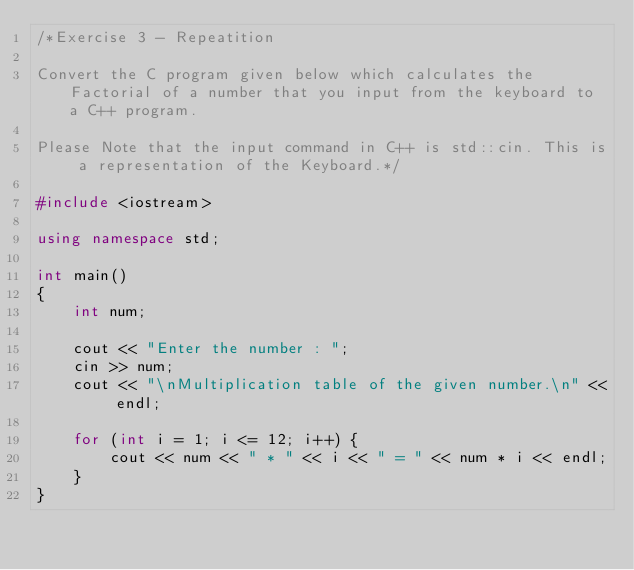Convert code to text. <code><loc_0><loc_0><loc_500><loc_500><_C++_>/*Exercise 3 - Repeatition

Convert the C program given below which calculates the Factorial of a number that you input from the keyboard to a C++ program.

Please Note that the input command in C++ is std::cin. This is a representation of the Keyboard.*/

#include <iostream>

using namespace std;

int main()
{
    int num;

    cout << "Enter the number : ";
    cin >> num;
    cout << "\nMultiplication table of the given number.\n" << endl;

    for (int i = 1; i <= 12; i++) {
        cout << num << " * " << i << " = " << num * i << endl;
    }
}
</code> 